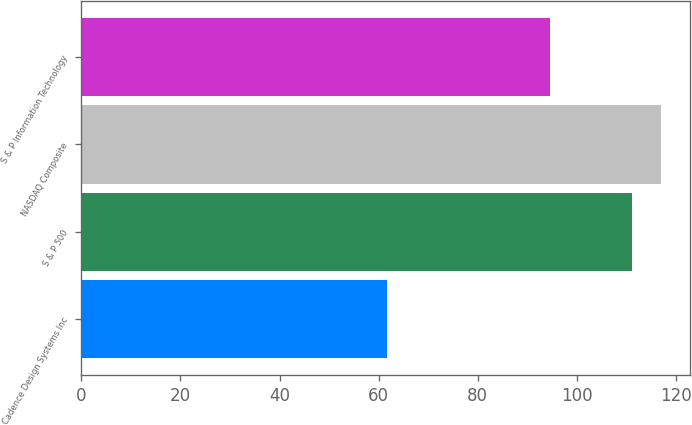Convert chart. <chart><loc_0><loc_0><loc_500><loc_500><bar_chart><fcel>Cadence Design Systems Inc<fcel>S & P 500<fcel>NASDAQ Composite<fcel>S & P Information Technology<nl><fcel>61.65<fcel>111.15<fcel>117.07<fcel>94.5<nl></chart> 